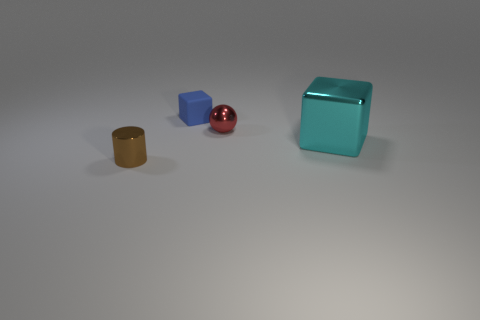Add 2 brown things. How many objects exist? 6 Subtract 1 blocks. How many blocks are left? 1 Subtract all balls. How many objects are left? 3 Subtract all yellow cubes. Subtract all purple balls. How many cubes are left? 2 Subtract all red shiny spheres. Subtract all tiny blue rubber cubes. How many objects are left? 2 Add 3 red metallic things. How many red metallic things are left? 4 Add 2 cylinders. How many cylinders exist? 3 Subtract 0 green cubes. How many objects are left? 4 